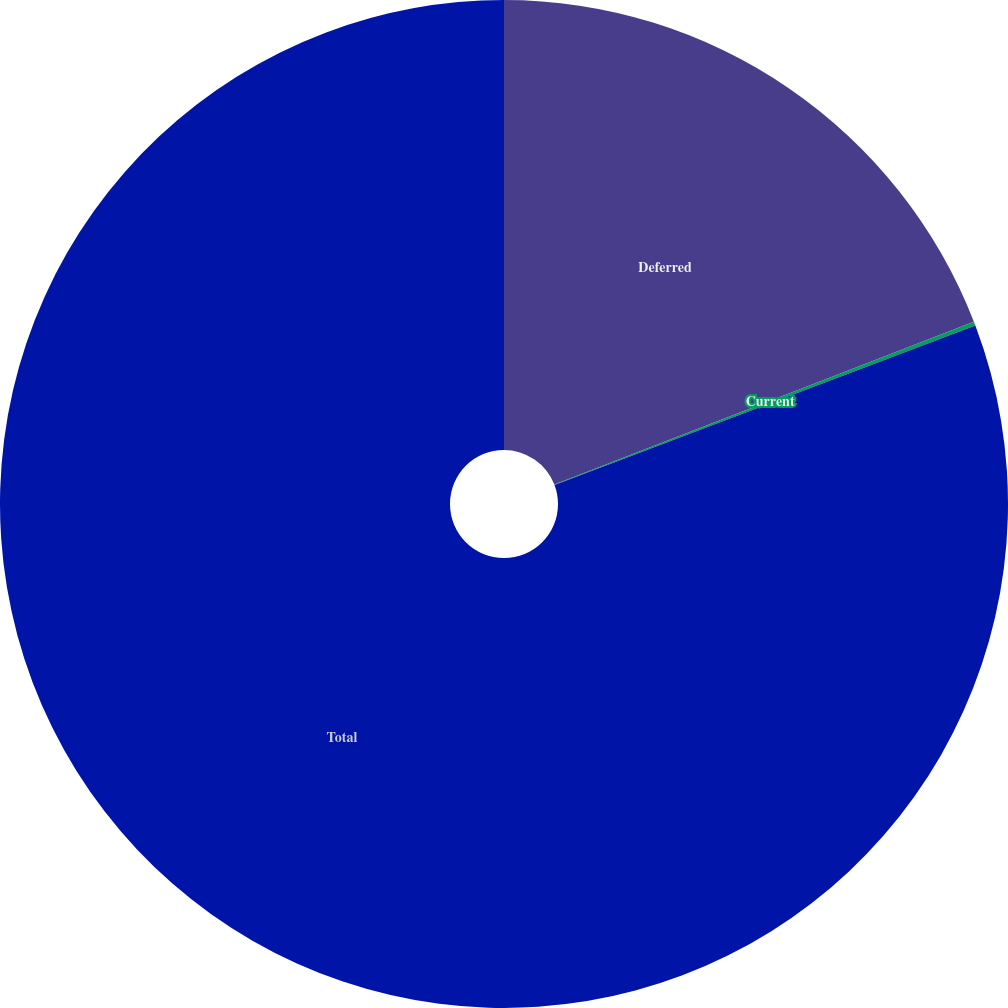Convert chart to OTSL. <chart><loc_0><loc_0><loc_500><loc_500><pie_chart><fcel>Deferred<fcel>Current<fcel>Total<nl><fcel>19.11%<fcel>0.13%<fcel>80.76%<nl></chart> 